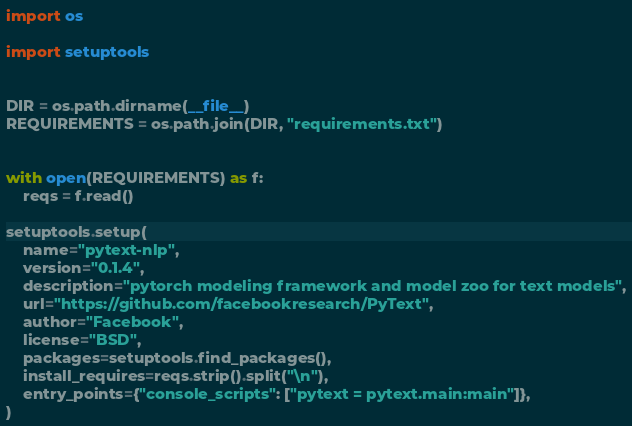<code> <loc_0><loc_0><loc_500><loc_500><_Python_>
import os

import setuptools


DIR = os.path.dirname(__file__)
REQUIREMENTS = os.path.join(DIR, "requirements.txt")


with open(REQUIREMENTS) as f:
    reqs = f.read()

setuptools.setup(
    name="pytext-nlp",
    version="0.1.4",
    description="pytorch modeling framework and model zoo for text models",
    url="https://github.com/facebookresearch/PyText",
    author="Facebook",
    license="BSD",
    packages=setuptools.find_packages(),
    install_requires=reqs.strip().split("\n"),
    entry_points={"console_scripts": ["pytext = pytext.main:main"]},
)
</code> 